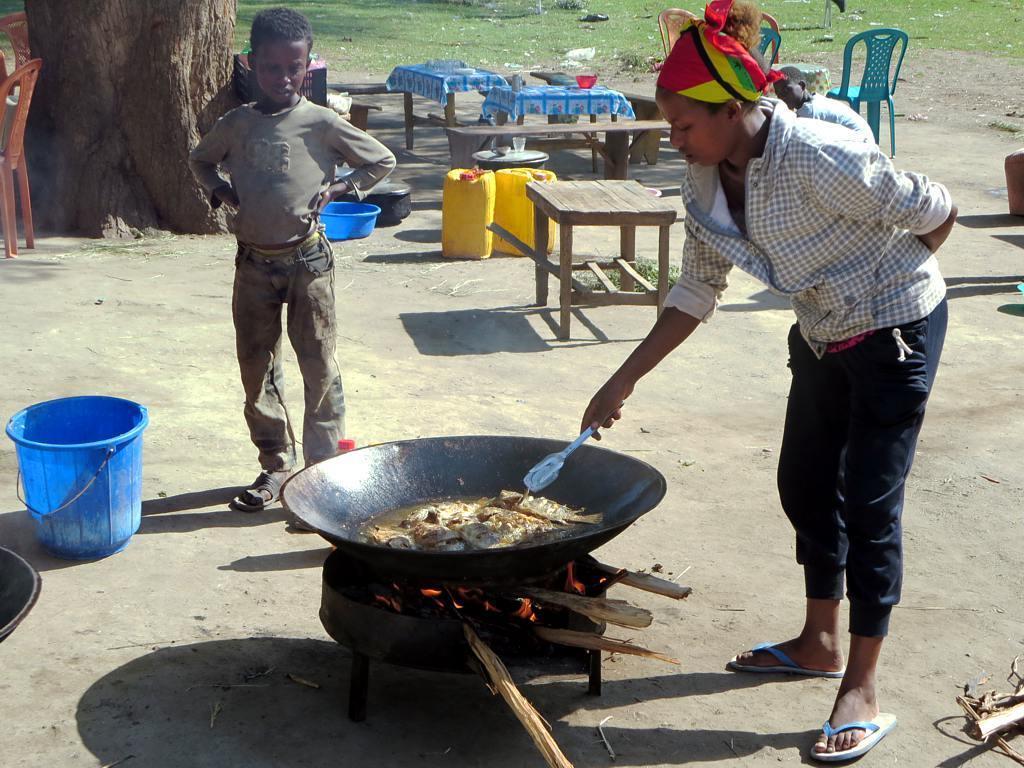Please provide a concise description of this image. In this image, we can see few peoples. The right side, women is cooking some food under this we can see fire and wooden pieces. On left side, the boy is standing near the blue bucket. The top of the image, we can see so many items, tables, can, basket, few items are placed on the tables. On left side, there is a trunk and chairs. 